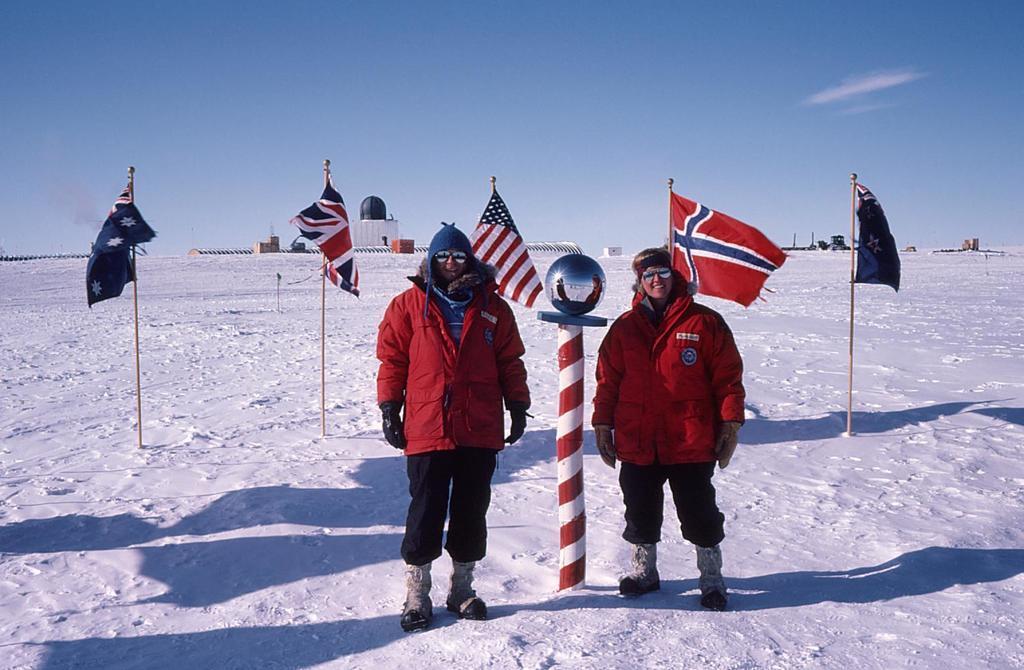How would you summarize this image in a sentence or two? In the image we can see two persons are standing on the snow and in between them there is a spherical ball on the stand and behind them there are flags to the poles on the ground. In the background there are buildings and clouds in the sky. 